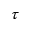<formula> <loc_0><loc_0><loc_500><loc_500>\tau</formula> 